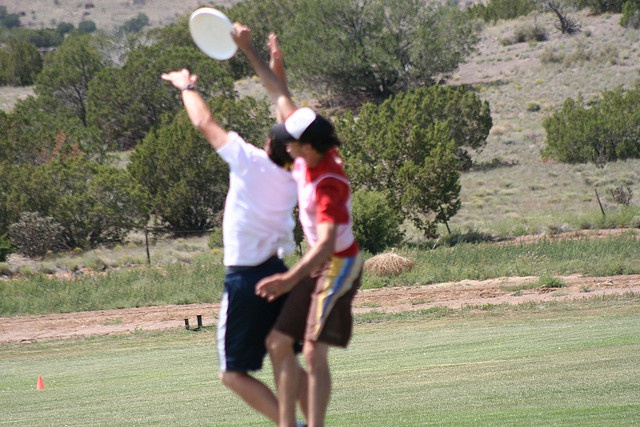Describe the objects in this image and their specific colors. I can see people in darkgray, black, gray, and maroon tones, people in darkgray, black, and lavender tones, and frisbee in darkgray and lightgray tones in this image. 